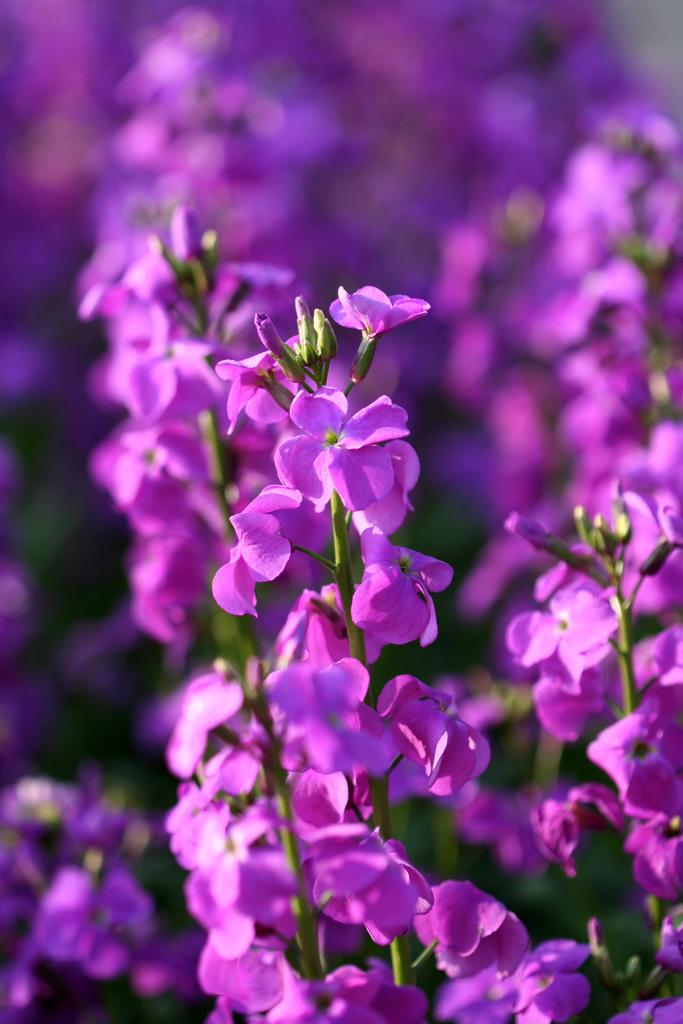What is the main subject of the image? The main subject of the image is many flowers. What color are the flowers in the image? The flowers in the image are in violet color. How many boats can be seen in the image? There are no boats present in the image; it features many violet flowers. Is there a duck swimming among the flowers in the image? There is no duck present in the image; it only features flowers. 